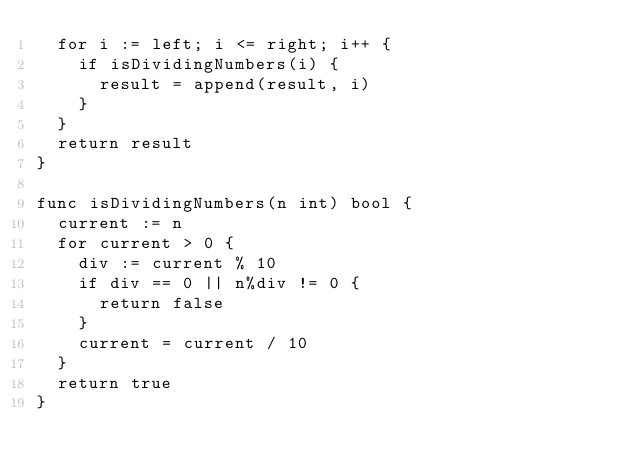<code> <loc_0><loc_0><loc_500><loc_500><_Go_>	for i := left; i <= right; i++ {
		if isDividingNumbers(i) {
			result = append(result, i)
		}
	}
	return result
}

func isDividingNumbers(n int) bool {
	current := n
	for current > 0 {
		div := current % 10
		if div == 0 || n%div != 0 {
			return false
		}
		current = current / 10
	}
	return true
}
</code> 